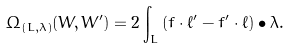Convert formula to latex. <formula><loc_0><loc_0><loc_500><loc_500>\Omega _ { ( L , \lambda ) } ( W , W ^ { \prime } ) = 2 \int _ { L } \left ( f \cdot \ell ^ { \prime } - f ^ { \prime } \cdot \ell \right ) \bullet \lambda .</formula> 